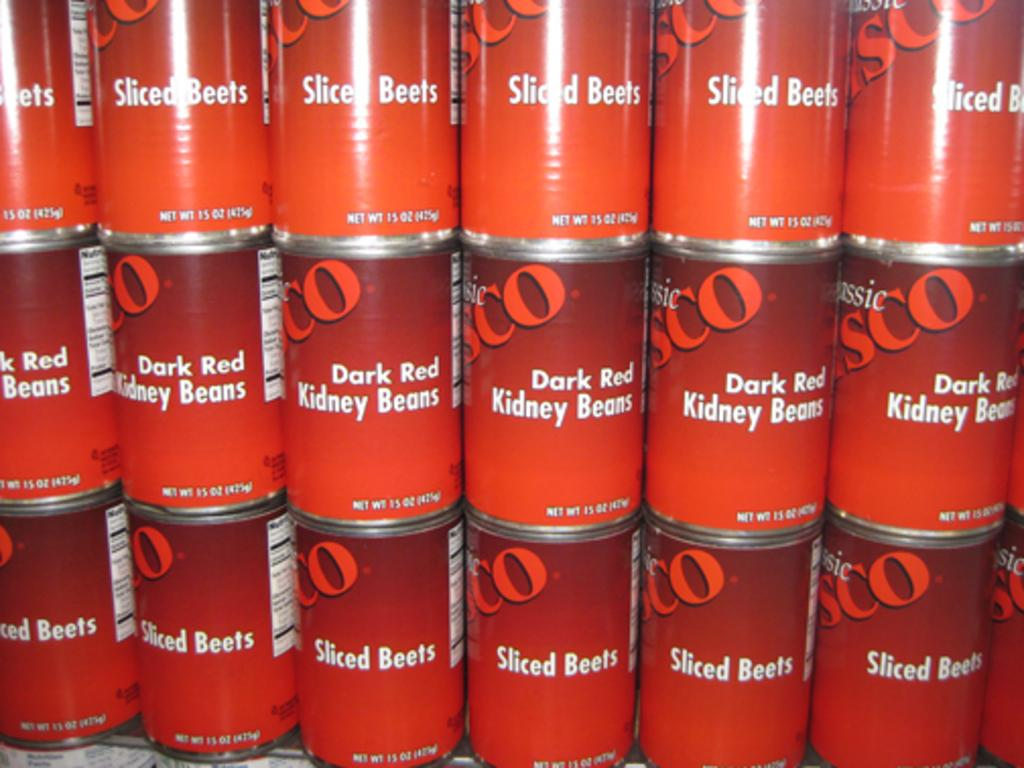<image>
Create a compact narrative representing the image presented. Several red cans stacked together, the bottom ones are sliced beets. 